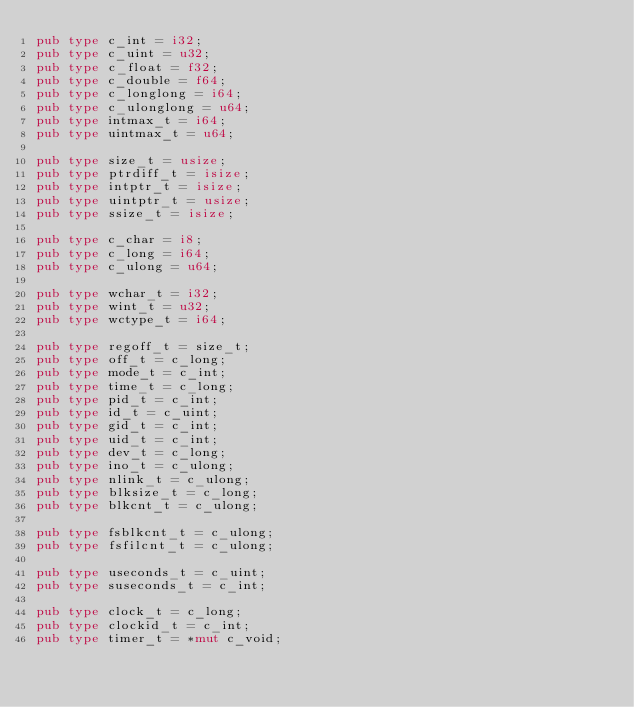Convert code to text. <code><loc_0><loc_0><loc_500><loc_500><_Rust_>pub type c_int = i32;
pub type c_uint = u32;
pub type c_float = f32;
pub type c_double = f64;
pub type c_longlong = i64;
pub type c_ulonglong = u64;
pub type intmax_t = i64;
pub type uintmax_t = u64;

pub type size_t = usize;
pub type ptrdiff_t = isize;
pub type intptr_t = isize;
pub type uintptr_t = usize;
pub type ssize_t = isize;

pub type c_char = i8;
pub type c_long = i64;
pub type c_ulong = u64;

pub type wchar_t = i32;
pub type wint_t = u32;
pub type wctype_t = i64;

pub type regoff_t = size_t;
pub type off_t = c_long;
pub type mode_t = c_int;
pub type time_t = c_long;
pub type pid_t = c_int;
pub type id_t = c_uint;
pub type gid_t = c_int;
pub type uid_t = c_int;
pub type dev_t = c_long;
pub type ino_t = c_ulong;
pub type nlink_t = c_ulong;
pub type blksize_t = c_long;
pub type blkcnt_t = c_ulong;

pub type fsblkcnt_t = c_ulong;
pub type fsfilcnt_t = c_ulong;

pub type useconds_t = c_uint;
pub type suseconds_t = c_int;

pub type clock_t = c_long;
pub type clockid_t = c_int;
pub type timer_t = *mut c_void;
</code> 